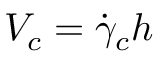Convert formula to latex. <formula><loc_0><loc_0><loc_500><loc_500>V _ { c } = \dot { \gamma } _ { c } h</formula> 